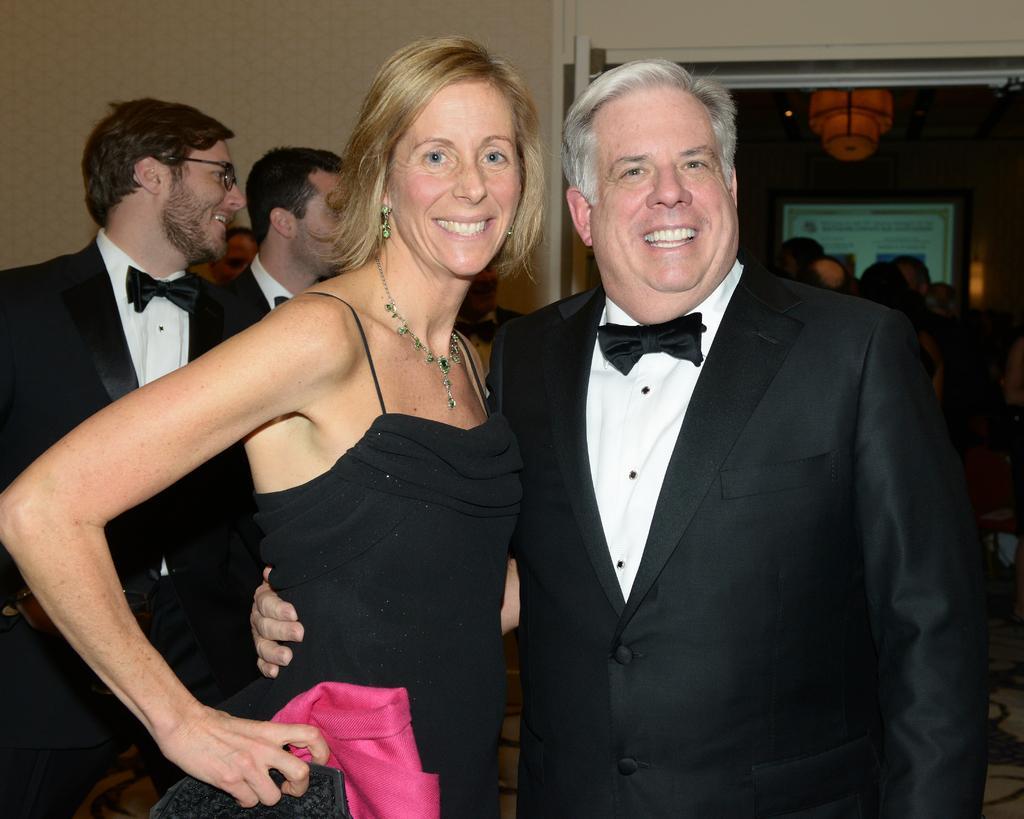Describe this image in one or two sentences. In this image, we can see persons wearing clothes. There is a wall in the top left of the image. 